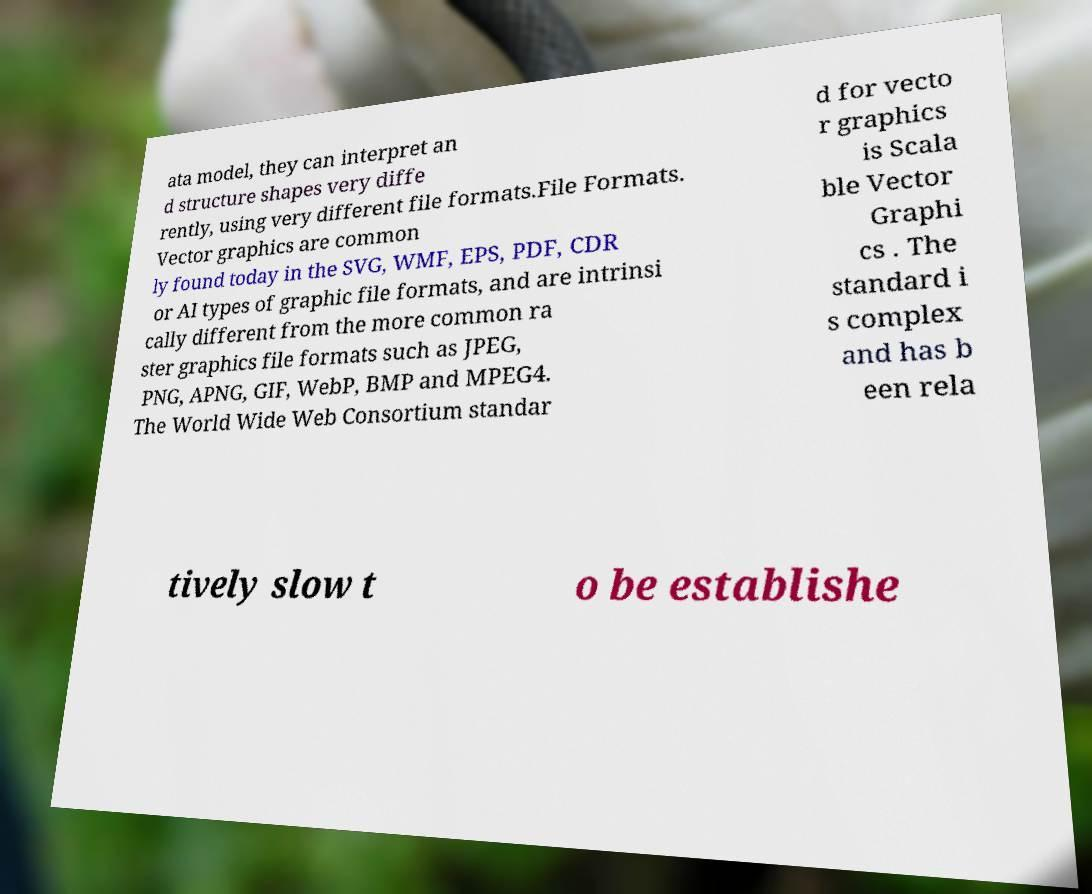There's text embedded in this image that I need extracted. Can you transcribe it verbatim? ata model, they can interpret an d structure shapes very diffe rently, using very different file formats.File Formats. Vector graphics are common ly found today in the SVG, WMF, EPS, PDF, CDR or AI types of graphic file formats, and are intrinsi cally different from the more common ra ster graphics file formats such as JPEG, PNG, APNG, GIF, WebP, BMP and MPEG4. The World Wide Web Consortium standar d for vecto r graphics is Scala ble Vector Graphi cs . The standard i s complex and has b een rela tively slow t o be establishe 